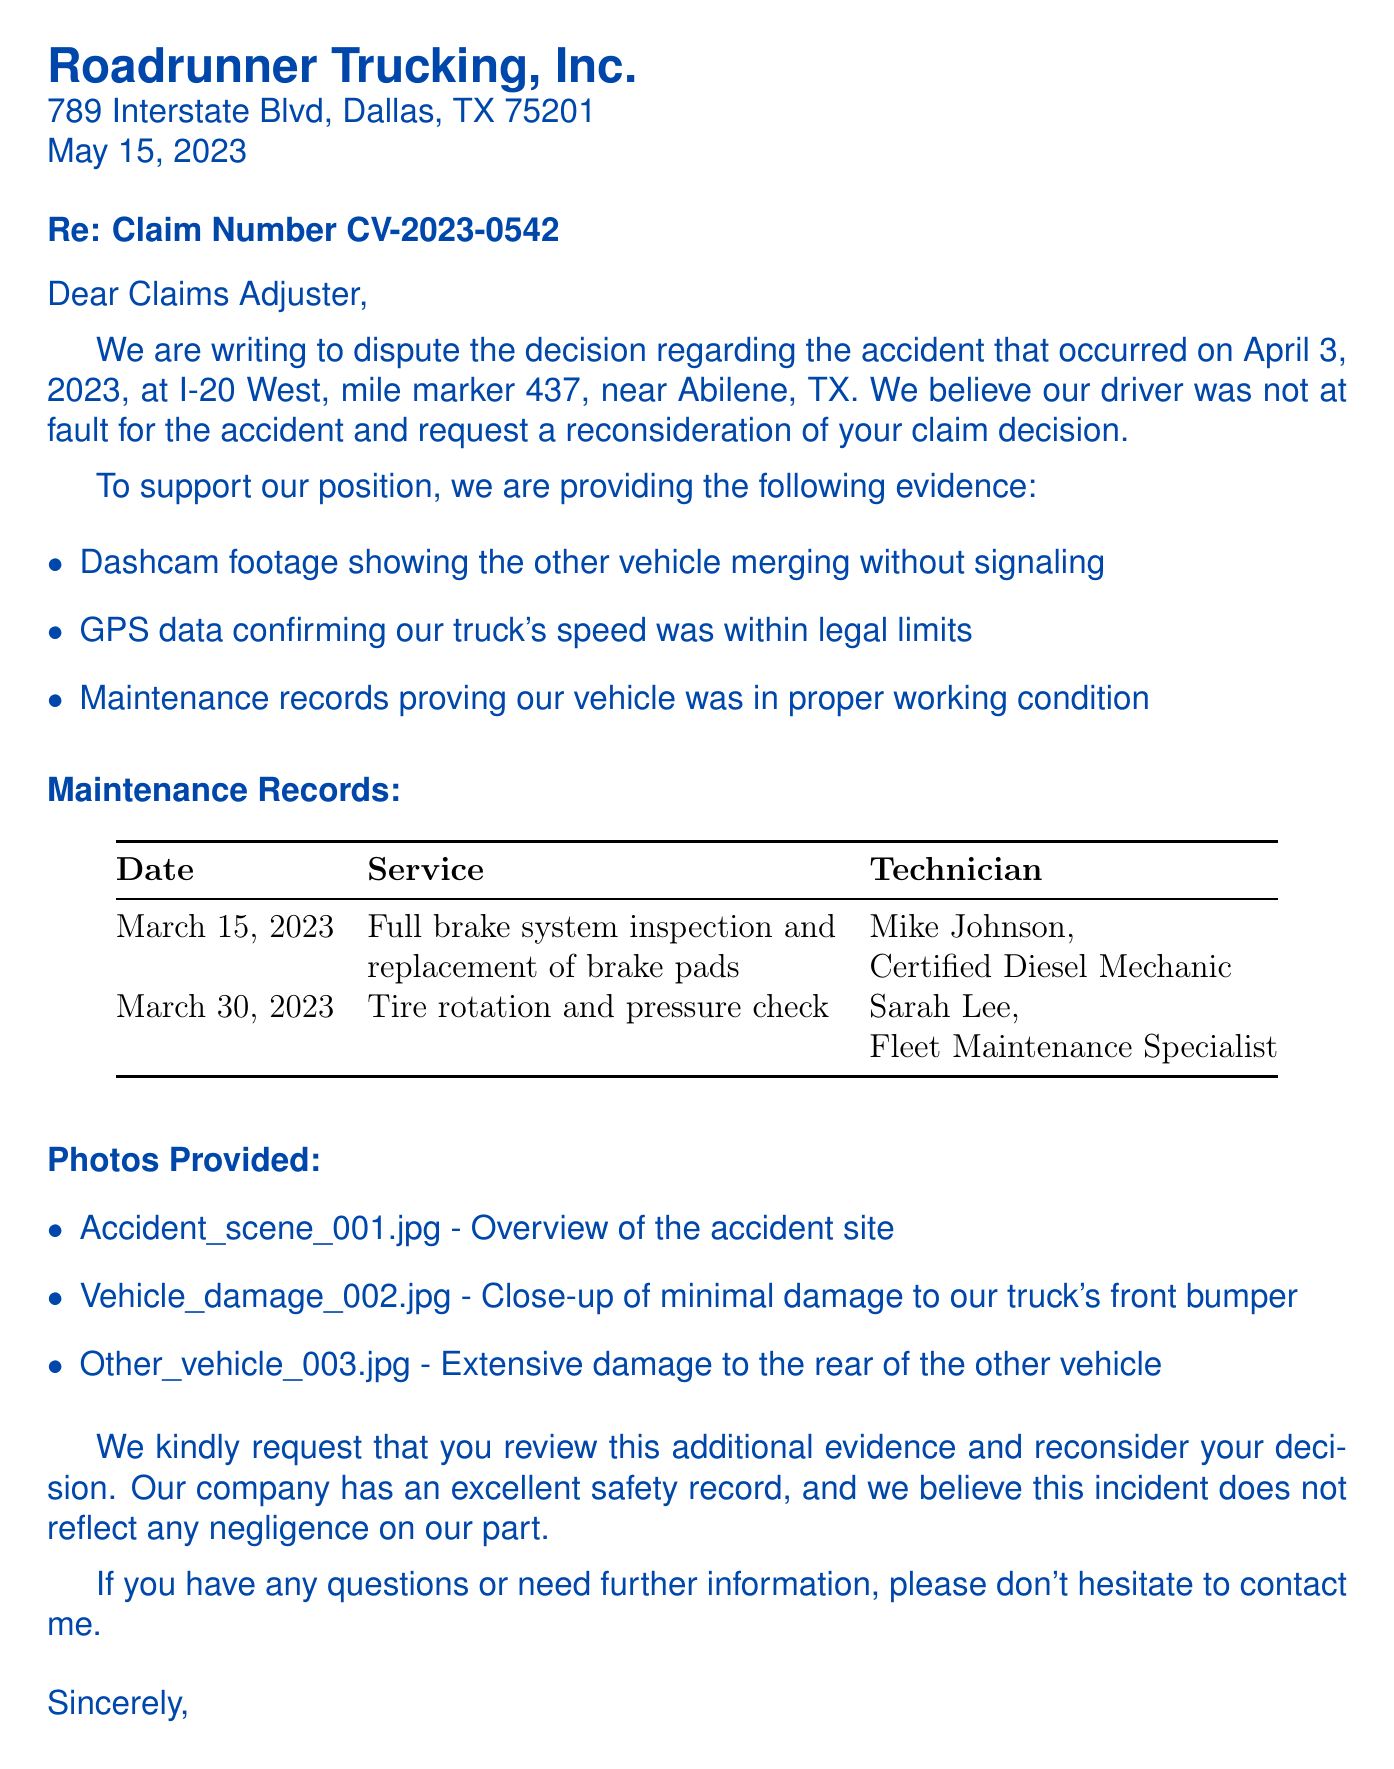What is the name of the trucking company? The name of the trucking company is found in the letter header.
Answer: Roadrunner Trucking, Inc What is the claim number? The claim number is mentioned in the subject of the letter.
Answer: CV-2023-0542 What date did the accident occur? The date of the accident is specified in the claim information section.
Answer: April 3, 2023 What is one piece of evidence provided? The evidence provided is listed in the document and includes different types of support.
Answer: Dashcam footage showing the other vehicle merging without signaling Who conducted the brake system inspection? The technician associated with the brake system inspection is found in the maintenance records.
Answer: Mike Johnson What is the reason for disputing the claim? The reason for disputing the claim is articulated in the letter body.
Answer: Driver was not at fault How many photos are provided? The photos provided are detailed in the section about evidence.
Answer: Three What type of maintenance was performed on March 30, 2023? The specific service type can be found in the maintenance records provided.
Answer: Tire rotation and pressure check What is the closing statement's request? The closing statement contains a specific request for reconsideration.
Answer: Review additional evidence and reconsider decision 